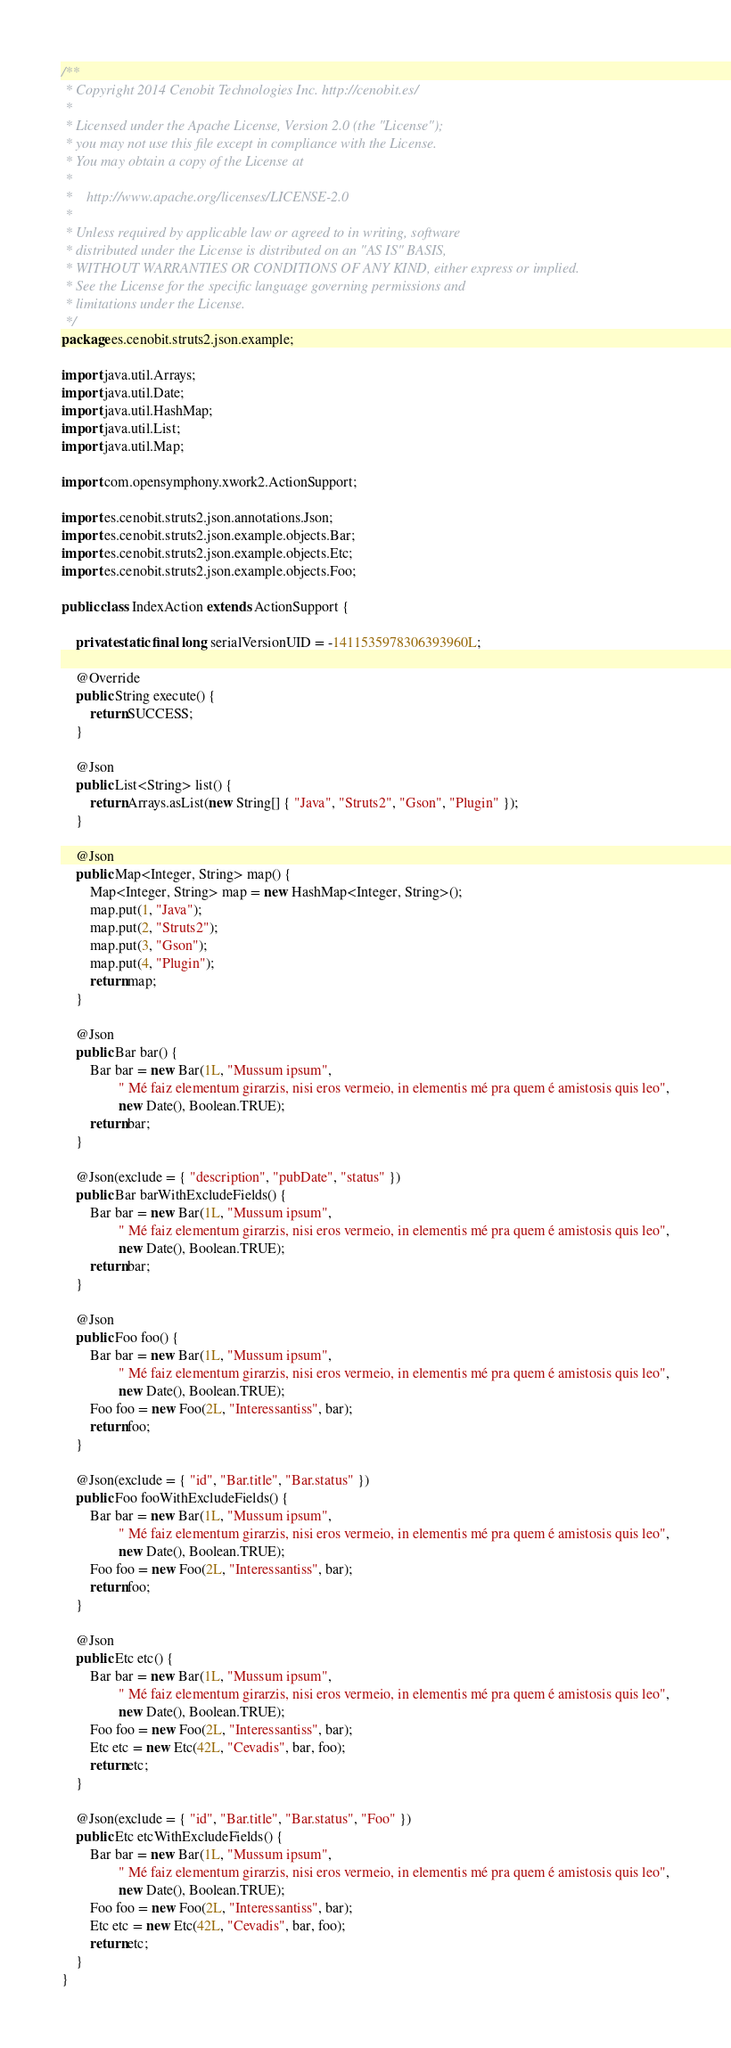<code> <loc_0><loc_0><loc_500><loc_500><_Java_>/**
 * Copyright 2014 Cenobit Technologies Inc. http://cenobit.es/
 *
 * Licensed under the Apache License, Version 2.0 (the "License");
 * you may not use this file except in compliance with the License.
 * You may obtain a copy of the License at
 *
 *    http://www.apache.org/licenses/LICENSE-2.0
 *
 * Unless required by applicable law or agreed to in writing, software
 * distributed under the License is distributed on an "AS IS" BASIS,
 * WITHOUT WARRANTIES OR CONDITIONS OF ANY KIND, either express or implied.
 * See the License for the specific language governing permissions and
 * limitations under the License. 
 */
package es.cenobit.struts2.json.example;

import java.util.Arrays;
import java.util.Date;
import java.util.HashMap;
import java.util.List;
import java.util.Map;

import com.opensymphony.xwork2.ActionSupport;

import es.cenobit.struts2.json.annotations.Json;
import es.cenobit.struts2.json.example.objects.Bar;
import es.cenobit.struts2.json.example.objects.Etc;
import es.cenobit.struts2.json.example.objects.Foo;

public class IndexAction extends ActionSupport {

    private static final long serialVersionUID = -1411535978306393960L;

    @Override
    public String execute() {
        return SUCCESS;
    }

    @Json
    public List<String> list() {
        return Arrays.asList(new String[] { "Java", "Struts2", "Gson", "Plugin" });
    }

    @Json
    public Map<Integer, String> map() {
        Map<Integer, String> map = new HashMap<Integer, String>();
        map.put(1, "Java");
        map.put(2, "Struts2");
        map.put(3, "Gson");
        map.put(4, "Plugin");
        return map;
    }

    @Json
    public Bar bar() {
        Bar bar = new Bar(1L, "Mussum ipsum",
                " Mé faiz elementum girarzis, nisi eros vermeio, in elementis mé pra quem é amistosis quis leo",
                new Date(), Boolean.TRUE);
        return bar;
    }

    @Json(exclude = { "description", "pubDate", "status" })
    public Bar barWithExcludeFields() {
        Bar bar = new Bar(1L, "Mussum ipsum",
                " Mé faiz elementum girarzis, nisi eros vermeio, in elementis mé pra quem é amistosis quis leo",
                new Date(), Boolean.TRUE);
        return bar;
    }

    @Json
    public Foo foo() {
        Bar bar = new Bar(1L, "Mussum ipsum",
                " Mé faiz elementum girarzis, nisi eros vermeio, in elementis mé pra quem é amistosis quis leo",
                new Date(), Boolean.TRUE);
        Foo foo = new Foo(2L, "Interessantiss", bar);
        return foo;
    }

    @Json(exclude = { "id", "Bar.title", "Bar.status" })
    public Foo fooWithExcludeFields() {
        Bar bar = new Bar(1L, "Mussum ipsum",
                " Mé faiz elementum girarzis, nisi eros vermeio, in elementis mé pra quem é amistosis quis leo",
                new Date(), Boolean.TRUE);
        Foo foo = new Foo(2L, "Interessantiss", bar);
        return foo;
    }

    @Json
    public Etc etc() {
        Bar bar = new Bar(1L, "Mussum ipsum",
                " Mé faiz elementum girarzis, nisi eros vermeio, in elementis mé pra quem é amistosis quis leo",
                new Date(), Boolean.TRUE);
        Foo foo = new Foo(2L, "Interessantiss", bar);
        Etc etc = new Etc(42L, "Cevadis", bar, foo);
        return etc;
    }

    @Json(exclude = { "id", "Bar.title", "Bar.status", "Foo" })
    public Etc etcWithExcludeFields() {
        Bar bar = new Bar(1L, "Mussum ipsum",
                " Mé faiz elementum girarzis, nisi eros vermeio, in elementis mé pra quem é amistosis quis leo",
                new Date(), Boolean.TRUE);
        Foo foo = new Foo(2L, "Interessantiss", bar);
        Etc etc = new Etc(42L, "Cevadis", bar, foo);
        return etc;
    }
}
</code> 